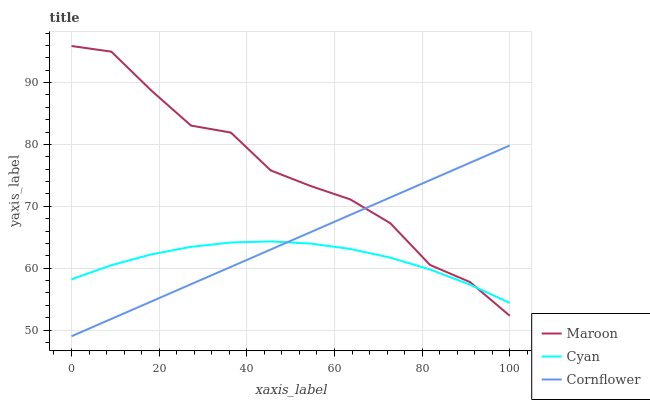Does Cyan have the minimum area under the curve?
Answer yes or no. Yes. Does Maroon have the maximum area under the curve?
Answer yes or no. Yes. Does Cornflower have the minimum area under the curve?
Answer yes or no. No. Does Cornflower have the maximum area under the curve?
Answer yes or no. No. Is Cornflower the smoothest?
Answer yes or no. Yes. Is Maroon the roughest?
Answer yes or no. Yes. Is Maroon the smoothest?
Answer yes or no. No. Is Cornflower the roughest?
Answer yes or no. No. Does Maroon have the lowest value?
Answer yes or no. No. Does Maroon have the highest value?
Answer yes or no. Yes. Does Cornflower have the highest value?
Answer yes or no. No. Does Cornflower intersect Cyan?
Answer yes or no. Yes. Is Cornflower less than Cyan?
Answer yes or no. No. Is Cornflower greater than Cyan?
Answer yes or no. No. 